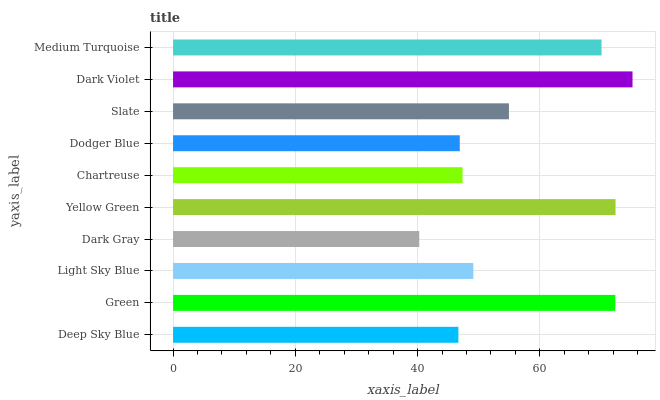Is Dark Gray the minimum?
Answer yes or no. Yes. Is Dark Violet the maximum?
Answer yes or no. Yes. Is Green the minimum?
Answer yes or no. No. Is Green the maximum?
Answer yes or no. No. Is Green greater than Deep Sky Blue?
Answer yes or no. Yes. Is Deep Sky Blue less than Green?
Answer yes or no. Yes. Is Deep Sky Blue greater than Green?
Answer yes or no. No. Is Green less than Deep Sky Blue?
Answer yes or no. No. Is Slate the high median?
Answer yes or no. Yes. Is Light Sky Blue the low median?
Answer yes or no. Yes. Is Light Sky Blue the high median?
Answer yes or no. No. Is Slate the low median?
Answer yes or no. No. 